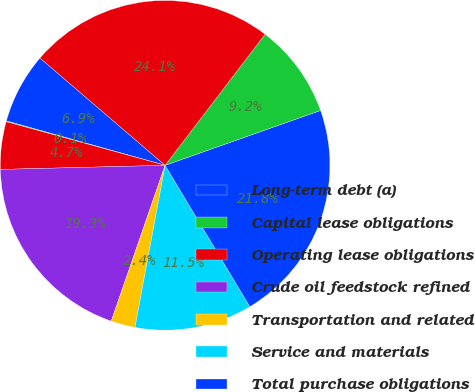Convert chart. <chart><loc_0><loc_0><loc_500><loc_500><pie_chart><fcel>Long-term debt (a)<fcel>Capital lease obligations<fcel>Operating lease obligations<fcel>Crude oil feedstock refined<fcel>Transportation and related<fcel>Service and materials<fcel>Total purchase obligations<fcel>Other long-term liabilities<fcel>Total contractual cash<nl><fcel>6.94%<fcel>0.08%<fcel>4.66%<fcel>19.31%<fcel>2.37%<fcel>11.52%<fcel>21.81%<fcel>9.23%<fcel>24.09%<nl></chart> 